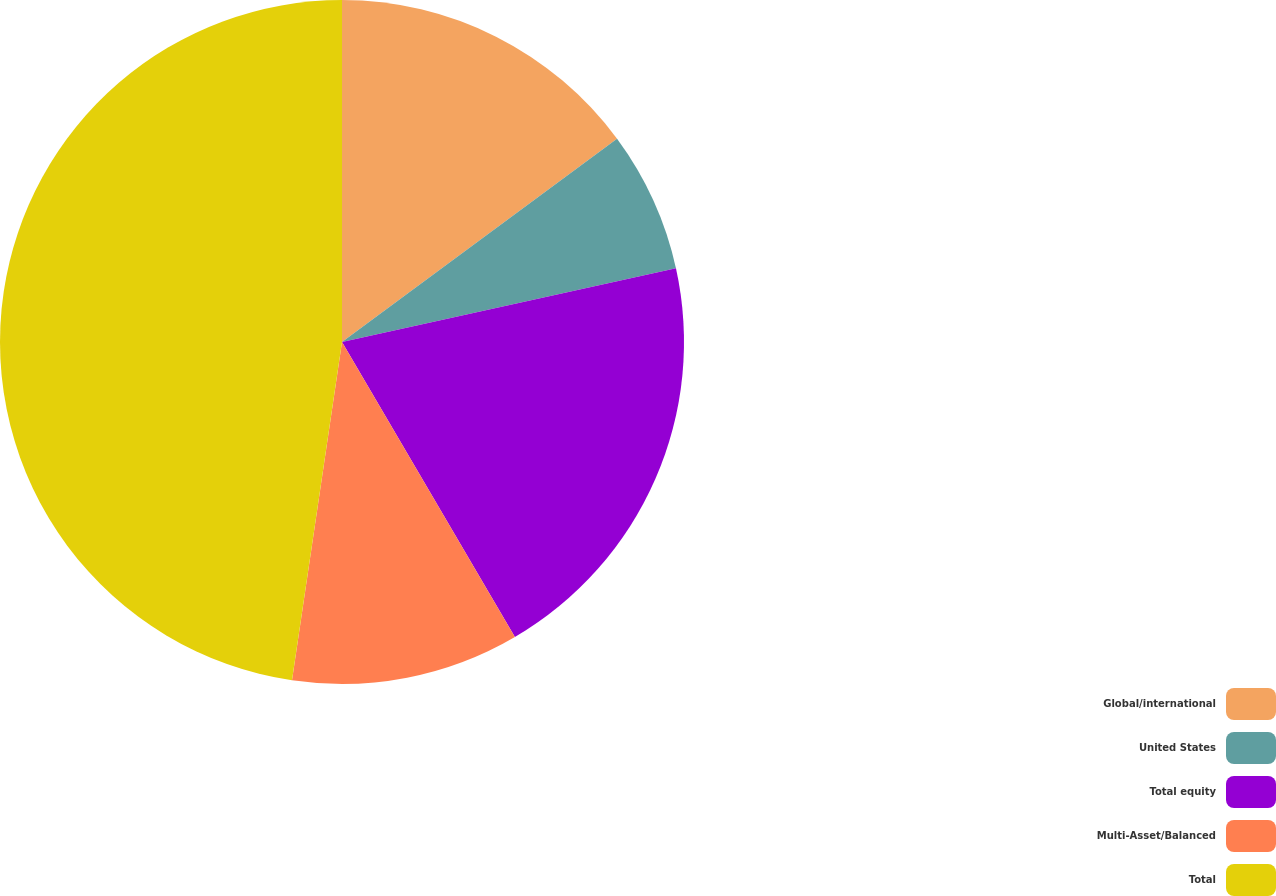Convert chart to OTSL. <chart><loc_0><loc_0><loc_500><loc_500><pie_chart><fcel>Global/international<fcel>United States<fcel>Total equity<fcel>Multi-Asset/Balanced<fcel>Total<nl><fcel>14.87%<fcel>6.67%<fcel>20.02%<fcel>10.77%<fcel>47.66%<nl></chart> 